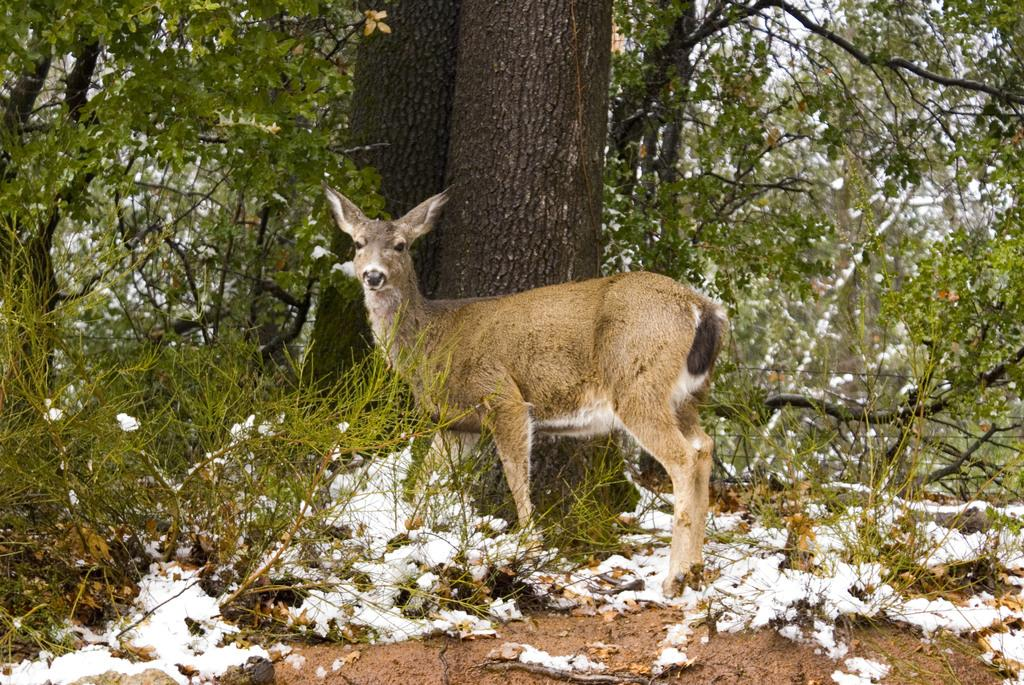What type of animal is on the ground in the image? The specific type of animal cannot be determined from the provided facts. What part of the trees can be seen in the image? The bark of trees is visible in the image. How many trees are in the group of trees in the image? The number of trees in the group cannot be determined from the provided facts. What is visible above the trees in the image? The sky is visible in the image. Where is the grandfather sitting and reading a book in the image? There is no grandfather or book present in the image. What type of books can be found in the library depicted in the image? There is no library depicted in the image. 